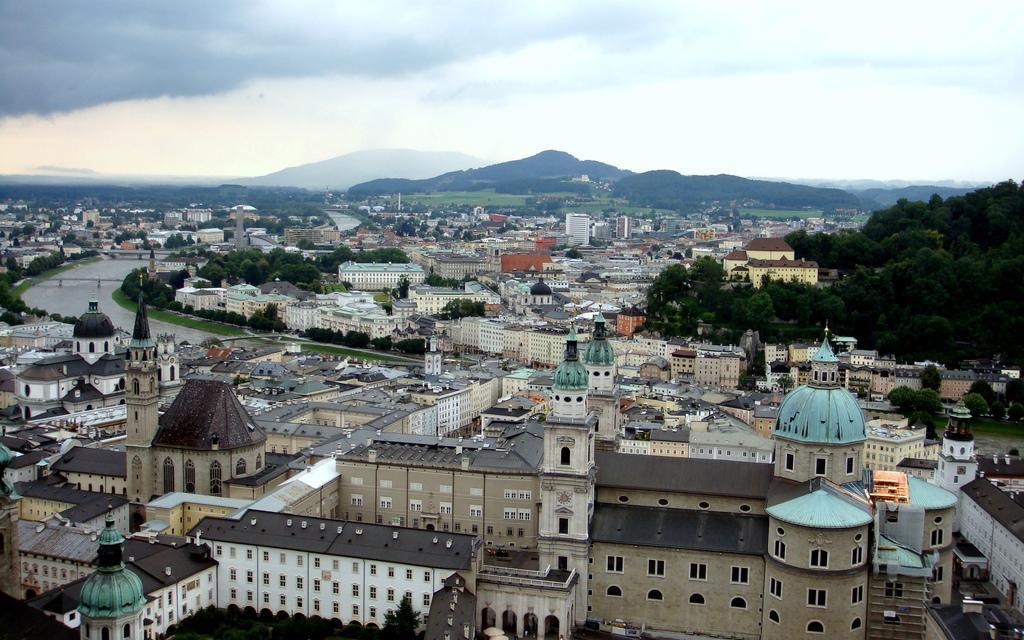Could you give a brief overview of what you see in this image? In the center of the image there is a bridge. There is water. There are buildings, trees. In the background of the image there are mountains and sky. 